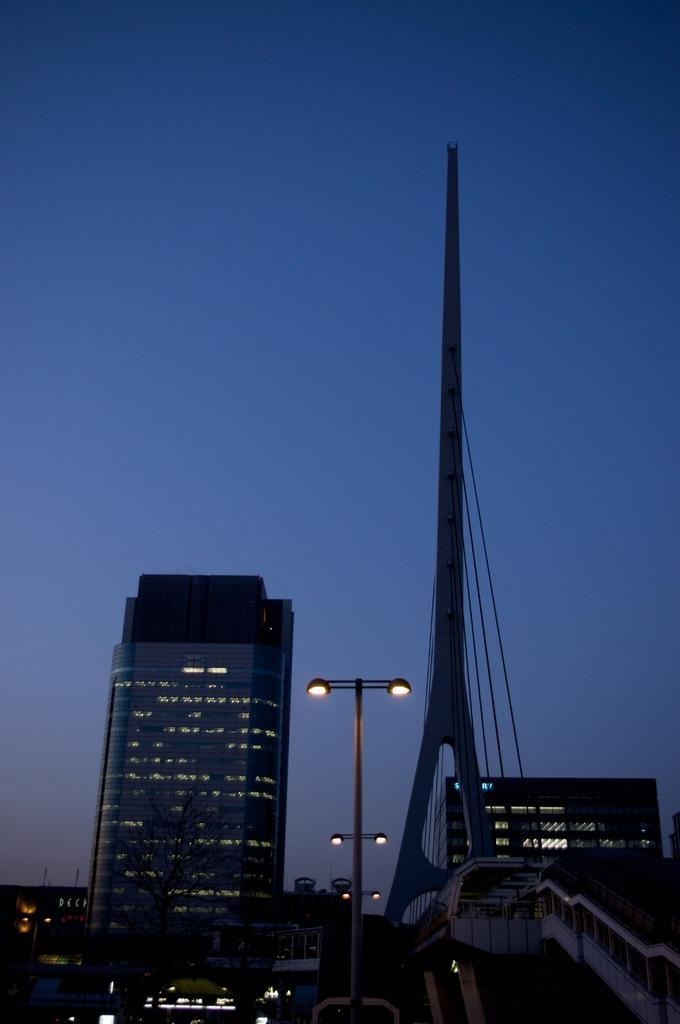How would you summarize this image in a sentence or two? This picture is clicked outside. In the foreground we can see the buildings, tower, cables, stair case, we can see the street lights attached to the poles. In the background there is a sky 